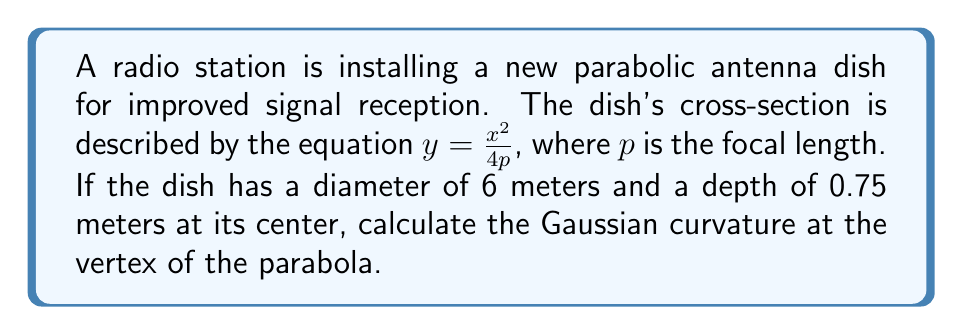Show me your answer to this math problem. Let's approach this step-by-step:

1) First, we need to find the value of $p$. We can do this using the given dimensions of the dish.

2) The diameter is 6 meters, so the radius is 3 meters. At the edge of the dish, $x = 3$ and $y = 0.75$.

3) Substituting these values into the equation of the parabola:

   $$0.75 = \frac{3^2}{4p}$$

4) Solving for $p$:

   $$p = \frac{3^2}{4(0.75)} = 3$$

5) Now that we have $p$, we can write the equation of our parabola as:

   $$y = \frac{x^2}{12}$$

6) For a surface of revolution generated by rotating a curve $y = f(x)$ around the y-axis, the Gaussian curvature $K$ at a point $(x, y)$ is given by:

   $$K = -\frac{f''(x)}{(1 + [f'(x)]^2)^2}$$

7) We need to calculate $f'(x)$ and $f''(x)$:

   $$f'(x) = \frac{x}{6}$$
   $$f''(x) = \frac{1}{6}$$

8) At the vertex of the parabola, $x = 0$. Substituting this into our curvature formula:

   $$K = -\frac{\frac{1}{6}}{(1 + [0]^2)^2} = -\frac{1}{6}$$

Therefore, the Gaussian curvature at the vertex of the parabola is $-\frac{1}{6}$.
Answer: $-\frac{1}{6}$ 